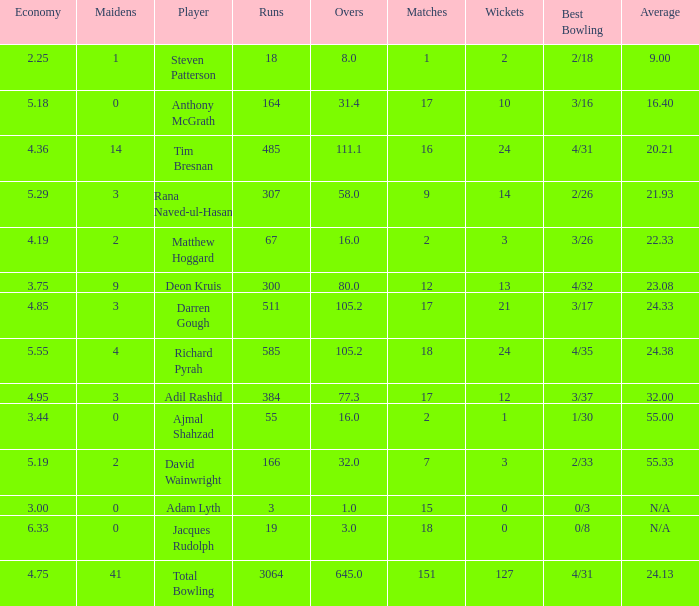What is the lowest Overs with a Run that is 18? 8.0. 